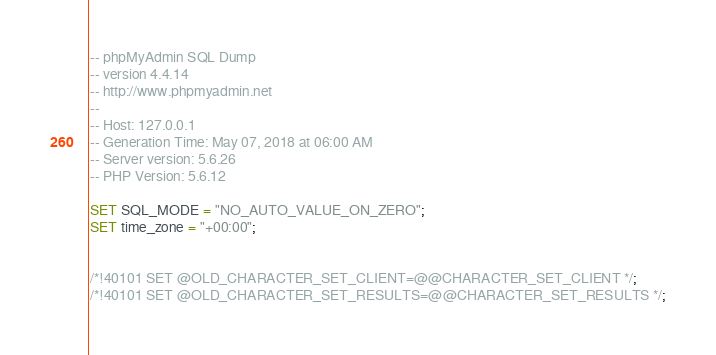<code> <loc_0><loc_0><loc_500><loc_500><_SQL_>-- phpMyAdmin SQL Dump
-- version 4.4.14
-- http://www.phpmyadmin.net
--
-- Host: 127.0.0.1
-- Generation Time: May 07, 2018 at 06:00 AM
-- Server version: 5.6.26
-- PHP Version: 5.6.12

SET SQL_MODE = "NO_AUTO_VALUE_ON_ZERO";
SET time_zone = "+00:00";


/*!40101 SET @OLD_CHARACTER_SET_CLIENT=@@CHARACTER_SET_CLIENT */;
/*!40101 SET @OLD_CHARACTER_SET_RESULTS=@@CHARACTER_SET_RESULTS */;</code> 